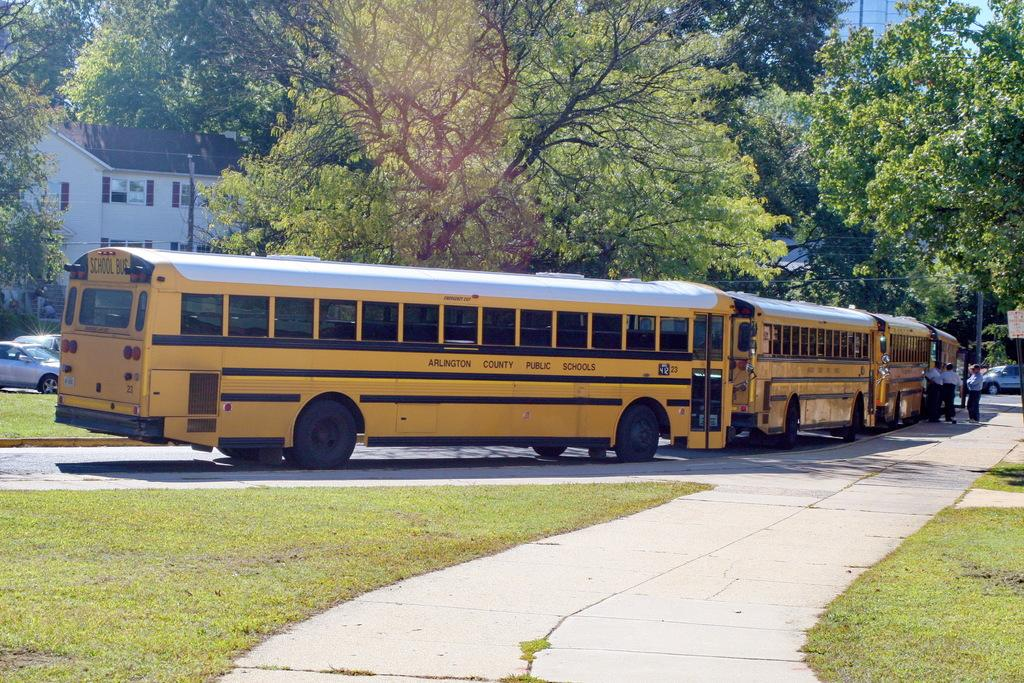What types of vehicles are in the image? There are buses and cars in the image. What can be seen in the background of the image? There are trees and buildings in the background of the image. Who or what else is present in the image? People are present in the image. What type of ground surface is visible in the image? There is grass in the image. What type of material is used for the windows in the image? There are glass windows in the image. Where is the sink located in the image? There is no sink present in the image. What type of vegetable is being served on the table in the image? There is no table or vegetable present in the image. 